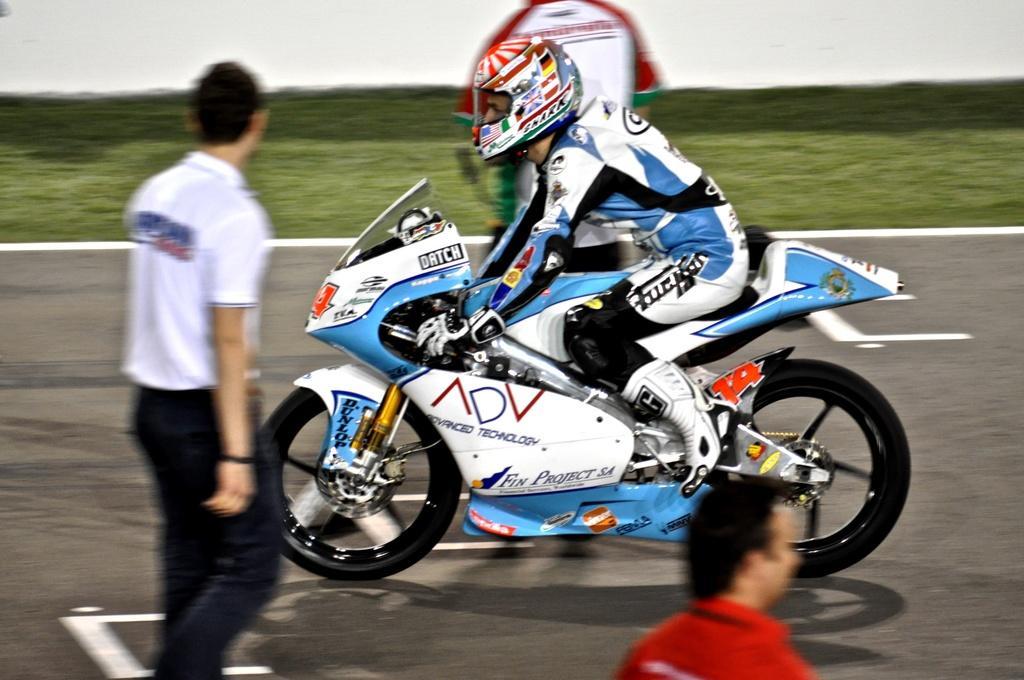Describe this image in one or two sentences. Here in this picture we can see a person sitting on a motor bike, which is present on the road over there and he is wearing racing suit and helmet on him and we can also see people standing and walking on the road here and there and beside him we can see some part of ground is covered with grass over there. 